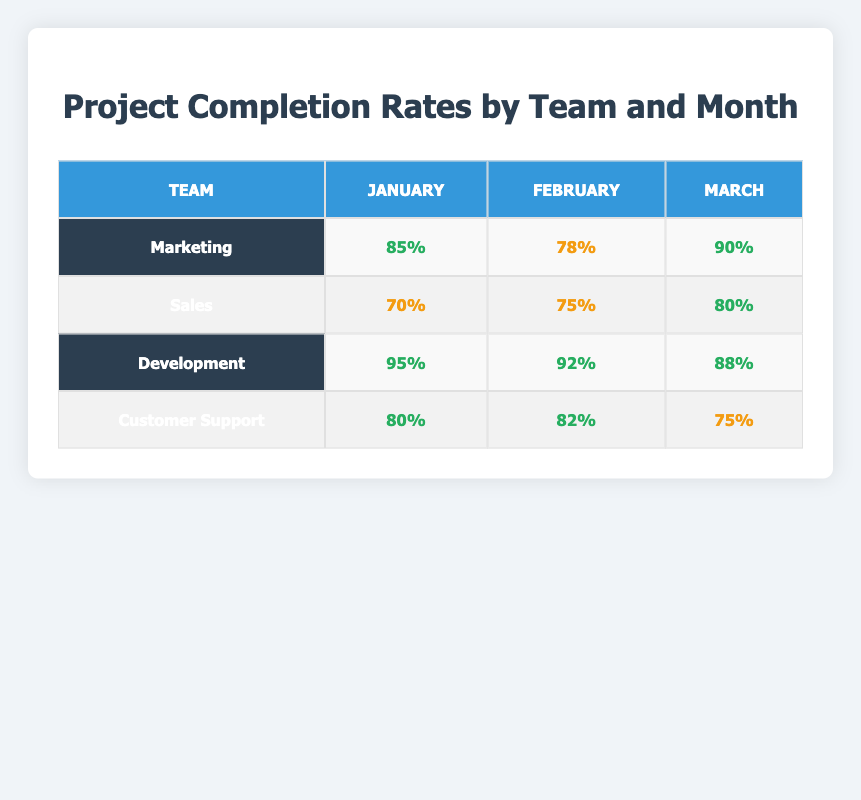What is the project completion rate for the Development team in February? According to the table, the Development team's completion rate for February is the value listed in the respective cell, which is 92%.
Answer: 92% Which team had the highest completion rate in March? By comparing the completion rates for each team in March, Development has 88%, Marketing has 90%, Sales has 80%, and Customer Support has 75%. The highest among these is Marketing with 90%.
Answer: Marketing What is the average completion rate for the Sales team over the three months? The Sales team's completion rates for January, February, and March are 70%, 75%, and 80%. To find the average, sum these values: 70 + 75 + 80 = 225. Then divide by 3 (the number of months): 225 / 3 = 75.
Answer: 75 Did the Customer Support team ever exceed an 80% completion rate? Looking at the completion rates for Customer Support in each month, January shows 80%, February shows 82%, and March shows 75%. Since they reached 82% in February, the answer is yes.
Answer: Yes Which team showed the largest increase in completion rate from January to February? We will look at the changes from January to February for each team: Marketing (85% to 78% = -7%), Sales (70% to 75% = +5%), Development (95% to 92% = -3%), Customer Support (80% to 82% = +2%). The largest increase is 5% for the Sales team.
Answer: Sales 